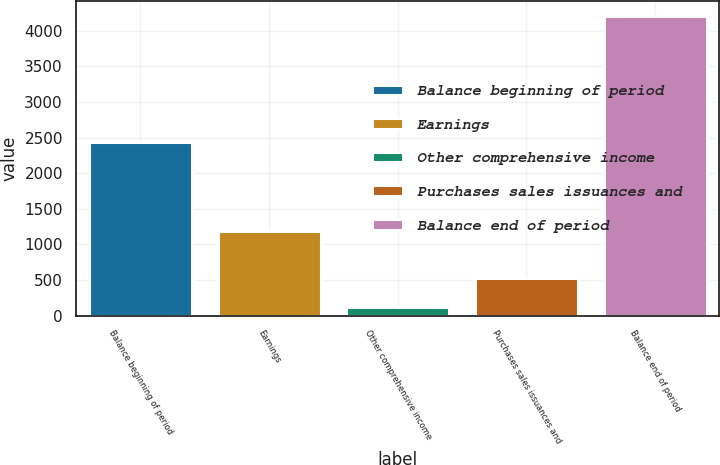Convert chart to OTSL. <chart><loc_0><loc_0><loc_500><loc_500><bar_chart><fcel>Balance beginning of period<fcel>Earnings<fcel>Other comprehensive income<fcel>Purchases sales issuances and<fcel>Balance end of period<nl><fcel>2438<fcel>1191<fcel>119<fcel>527.4<fcel>4203<nl></chart> 